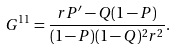Convert formula to latex. <formula><loc_0><loc_0><loc_500><loc_500>G ^ { 1 1 } = \frac { r P ^ { \prime } - Q ( 1 - P ) } { ( 1 - P ) ( 1 - Q ) ^ { 2 } r ^ { 2 } } .</formula> 